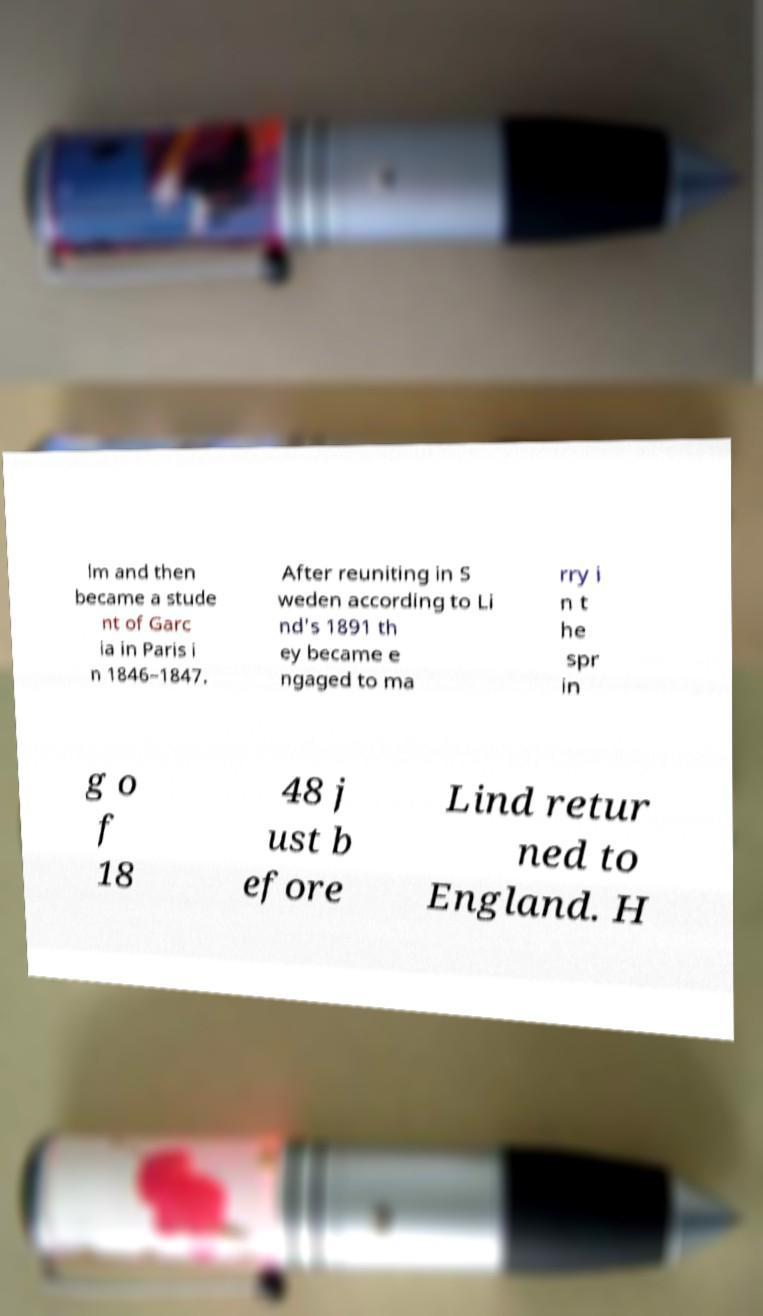Can you read and provide the text displayed in the image?This photo seems to have some interesting text. Can you extract and type it out for me? lm and then became a stude nt of Garc ia in Paris i n 1846–1847. After reuniting in S weden according to Li nd's 1891 th ey became e ngaged to ma rry i n t he spr in g o f 18 48 j ust b efore Lind retur ned to England. H 